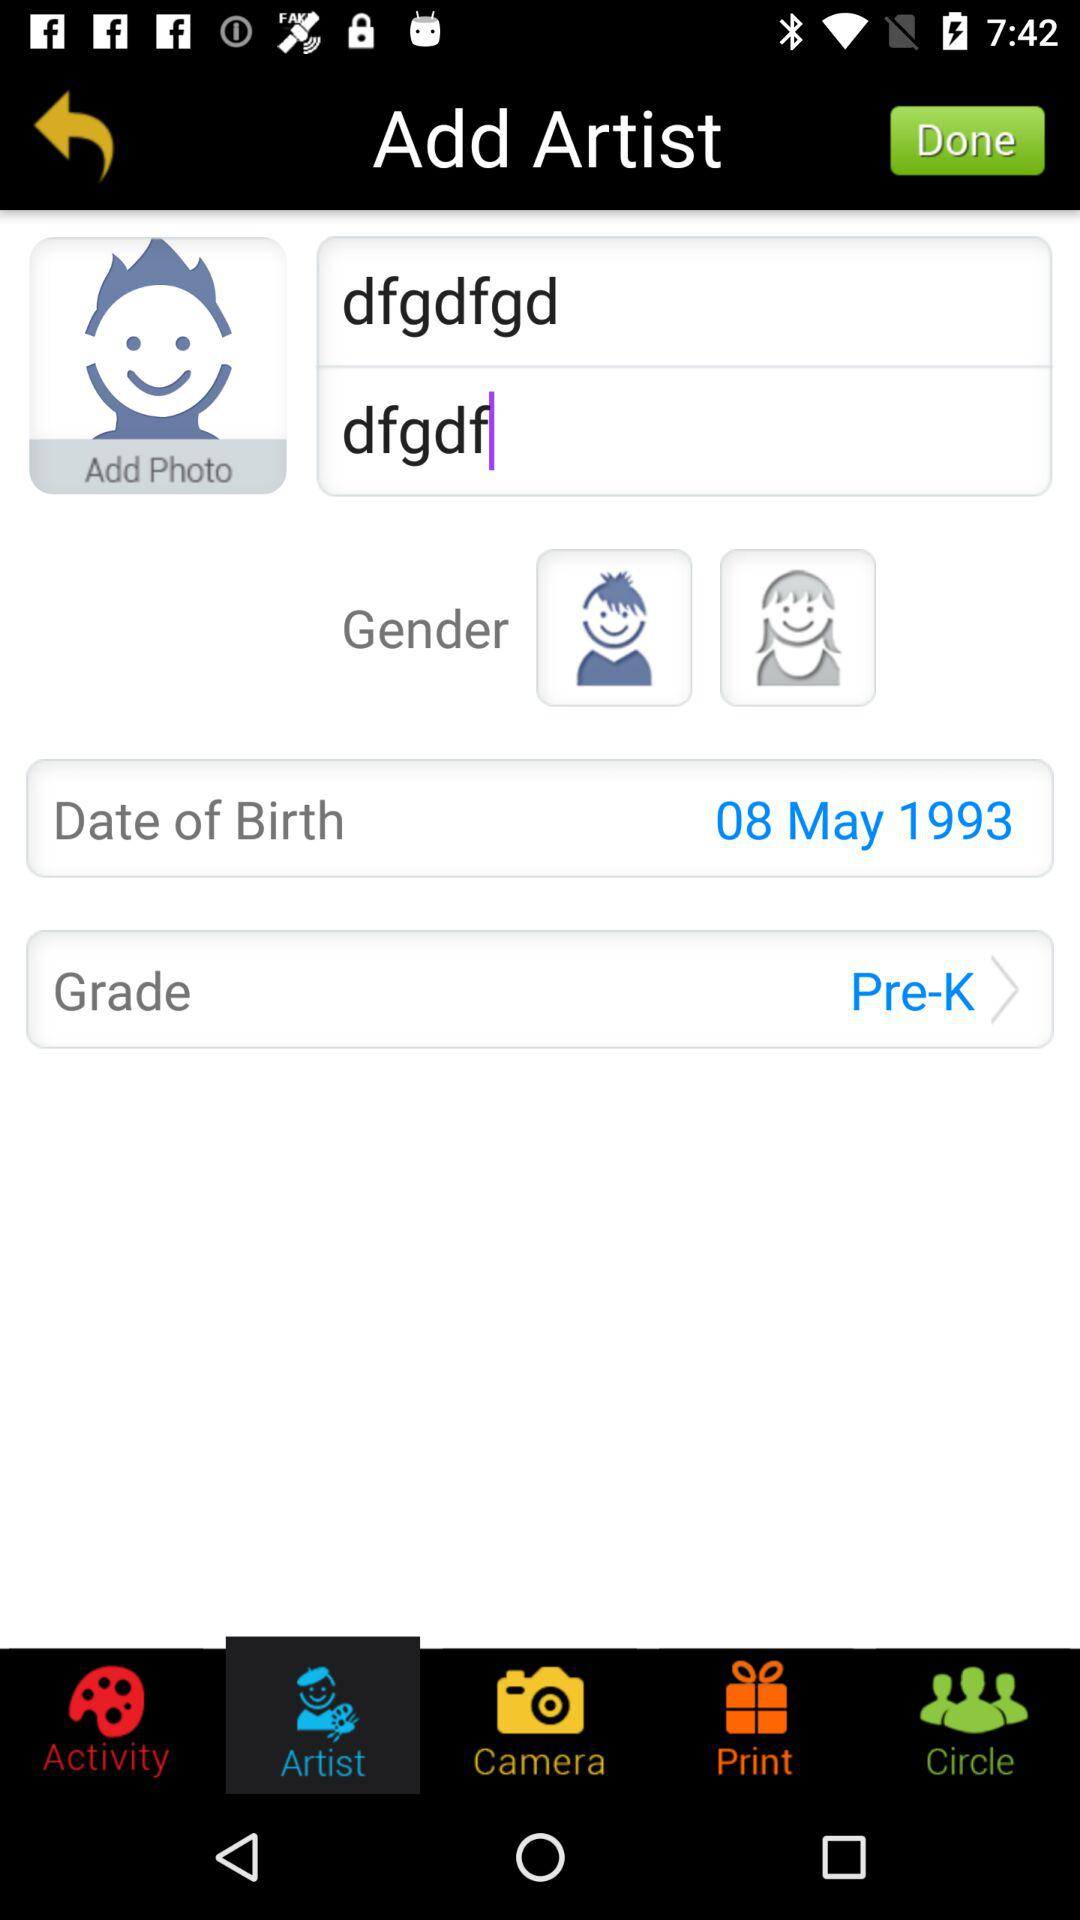Which tab is selected? The selected tab is "Artist". 